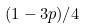Convert formula to latex. <formula><loc_0><loc_0><loc_500><loc_500>( 1 - 3 p ) / 4</formula> 